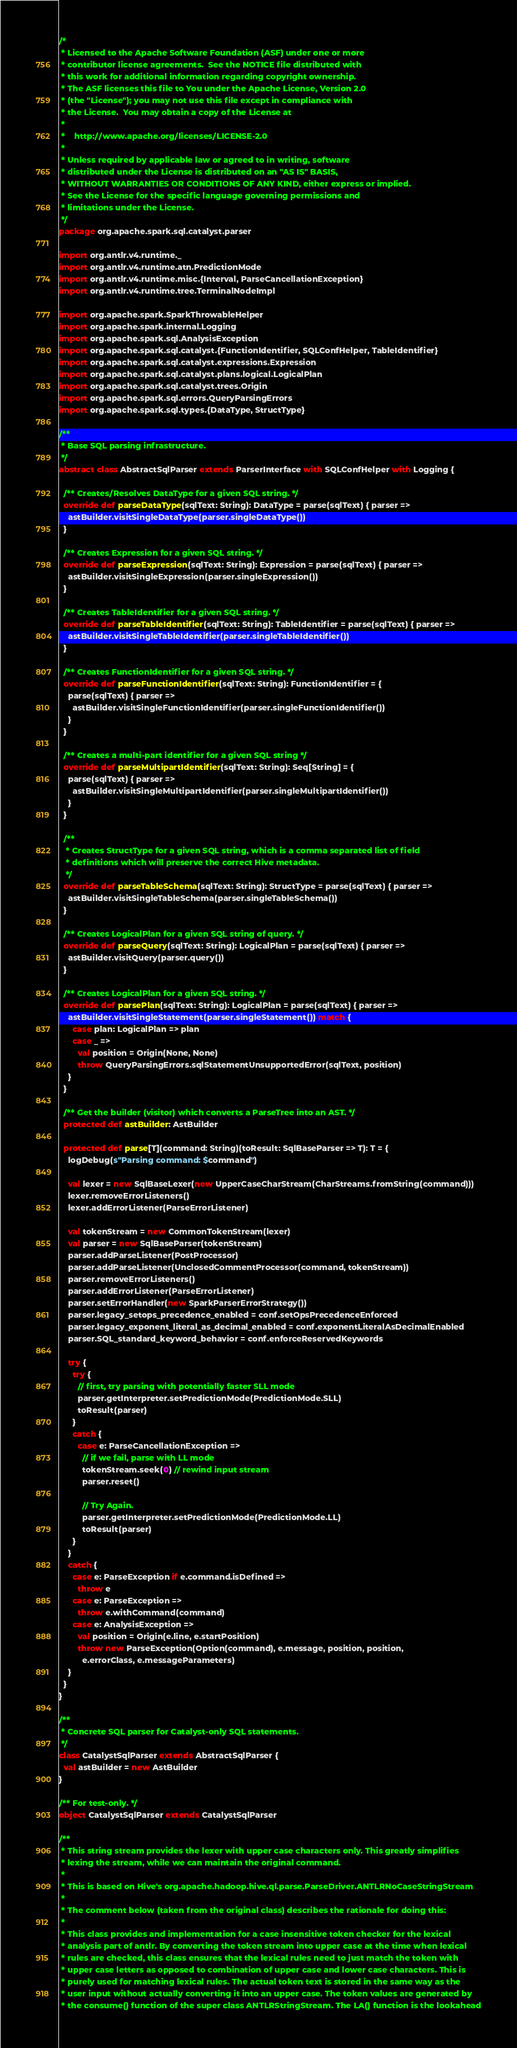Convert code to text. <code><loc_0><loc_0><loc_500><loc_500><_Scala_>/*
 * Licensed to the Apache Software Foundation (ASF) under one or more
 * contributor license agreements.  See the NOTICE file distributed with
 * this work for additional information regarding copyright ownership.
 * The ASF licenses this file to You under the Apache License, Version 2.0
 * (the "License"); you may not use this file except in compliance with
 * the License.  You may obtain a copy of the License at
 *
 *    http://www.apache.org/licenses/LICENSE-2.0
 *
 * Unless required by applicable law or agreed to in writing, software
 * distributed under the License is distributed on an "AS IS" BASIS,
 * WITHOUT WARRANTIES OR CONDITIONS OF ANY KIND, either express or implied.
 * See the License for the specific language governing permissions and
 * limitations under the License.
 */
package org.apache.spark.sql.catalyst.parser

import org.antlr.v4.runtime._
import org.antlr.v4.runtime.atn.PredictionMode
import org.antlr.v4.runtime.misc.{Interval, ParseCancellationException}
import org.antlr.v4.runtime.tree.TerminalNodeImpl

import org.apache.spark.SparkThrowableHelper
import org.apache.spark.internal.Logging
import org.apache.spark.sql.AnalysisException
import org.apache.spark.sql.catalyst.{FunctionIdentifier, SQLConfHelper, TableIdentifier}
import org.apache.spark.sql.catalyst.expressions.Expression
import org.apache.spark.sql.catalyst.plans.logical.LogicalPlan
import org.apache.spark.sql.catalyst.trees.Origin
import org.apache.spark.sql.errors.QueryParsingErrors
import org.apache.spark.sql.types.{DataType, StructType}

/**
 * Base SQL parsing infrastructure.
 */
abstract class AbstractSqlParser extends ParserInterface with SQLConfHelper with Logging {

  /** Creates/Resolves DataType for a given SQL string. */
  override def parseDataType(sqlText: String): DataType = parse(sqlText) { parser =>
    astBuilder.visitSingleDataType(parser.singleDataType())
  }

  /** Creates Expression for a given SQL string. */
  override def parseExpression(sqlText: String): Expression = parse(sqlText) { parser =>
    astBuilder.visitSingleExpression(parser.singleExpression())
  }

  /** Creates TableIdentifier for a given SQL string. */
  override def parseTableIdentifier(sqlText: String): TableIdentifier = parse(sqlText) { parser =>
    astBuilder.visitSingleTableIdentifier(parser.singleTableIdentifier())
  }

  /** Creates FunctionIdentifier for a given SQL string. */
  override def parseFunctionIdentifier(sqlText: String): FunctionIdentifier = {
    parse(sqlText) { parser =>
      astBuilder.visitSingleFunctionIdentifier(parser.singleFunctionIdentifier())
    }
  }

  /** Creates a multi-part identifier for a given SQL string */
  override def parseMultipartIdentifier(sqlText: String): Seq[String] = {
    parse(sqlText) { parser =>
      astBuilder.visitSingleMultipartIdentifier(parser.singleMultipartIdentifier())
    }
  }

  /**
   * Creates StructType for a given SQL string, which is a comma separated list of field
   * definitions which will preserve the correct Hive metadata.
   */
  override def parseTableSchema(sqlText: String): StructType = parse(sqlText) { parser =>
    astBuilder.visitSingleTableSchema(parser.singleTableSchema())
  }

  /** Creates LogicalPlan for a given SQL string of query. */
  override def parseQuery(sqlText: String): LogicalPlan = parse(sqlText) { parser =>
    astBuilder.visitQuery(parser.query())
  }

  /** Creates LogicalPlan for a given SQL string. */
  override def parsePlan(sqlText: String): LogicalPlan = parse(sqlText) { parser =>
    astBuilder.visitSingleStatement(parser.singleStatement()) match {
      case plan: LogicalPlan => plan
      case _ =>
        val position = Origin(None, None)
        throw QueryParsingErrors.sqlStatementUnsupportedError(sqlText, position)
    }
  }

  /** Get the builder (visitor) which converts a ParseTree into an AST. */
  protected def astBuilder: AstBuilder

  protected def parse[T](command: String)(toResult: SqlBaseParser => T): T = {
    logDebug(s"Parsing command: $command")

    val lexer = new SqlBaseLexer(new UpperCaseCharStream(CharStreams.fromString(command)))
    lexer.removeErrorListeners()
    lexer.addErrorListener(ParseErrorListener)

    val tokenStream = new CommonTokenStream(lexer)
    val parser = new SqlBaseParser(tokenStream)
    parser.addParseListener(PostProcessor)
    parser.addParseListener(UnclosedCommentProcessor(command, tokenStream))
    parser.removeErrorListeners()
    parser.addErrorListener(ParseErrorListener)
    parser.setErrorHandler(new SparkParserErrorStrategy())
    parser.legacy_setops_precedence_enabled = conf.setOpsPrecedenceEnforced
    parser.legacy_exponent_literal_as_decimal_enabled = conf.exponentLiteralAsDecimalEnabled
    parser.SQL_standard_keyword_behavior = conf.enforceReservedKeywords

    try {
      try {
        // first, try parsing with potentially faster SLL mode
        parser.getInterpreter.setPredictionMode(PredictionMode.SLL)
        toResult(parser)
      }
      catch {
        case e: ParseCancellationException =>
          // if we fail, parse with LL mode
          tokenStream.seek(0) // rewind input stream
          parser.reset()

          // Try Again.
          parser.getInterpreter.setPredictionMode(PredictionMode.LL)
          toResult(parser)
      }
    }
    catch {
      case e: ParseException if e.command.isDefined =>
        throw e
      case e: ParseException =>
        throw e.withCommand(command)
      case e: AnalysisException =>
        val position = Origin(e.line, e.startPosition)
        throw new ParseException(Option(command), e.message, position, position,
          e.errorClass, e.messageParameters)
    }
  }
}

/**
 * Concrete SQL parser for Catalyst-only SQL statements.
 */
class CatalystSqlParser extends AbstractSqlParser {
  val astBuilder = new AstBuilder
}

/** For test-only. */
object CatalystSqlParser extends CatalystSqlParser

/**
 * This string stream provides the lexer with upper case characters only. This greatly simplifies
 * lexing the stream, while we can maintain the original command.
 *
 * This is based on Hive's org.apache.hadoop.hive.ql.parse.ParseDriver.ANTLRNoCaseStringStream
 *
 * The comment below (taken from the original class) describes the rationale for doing this:
 *
 * This class provides and implementation for a case insensitive token checker for the lexical
 * analysis part of antlr. By converting the token stream into upper case at the time when lexical
 * rules are checked, this class ensures that the lexical rules need to just match the token with
 * upper case letters as opposed to combination of upper case and lower case characters. This is
 * purely used for matching lexical rules. The actual token text is stored in the same way as the
 * user input without actually converting it into an upper case. The token values are generated by
 * the consume() function of the super class ANTLRStringStream. The LA() function is the lookahead</code> 